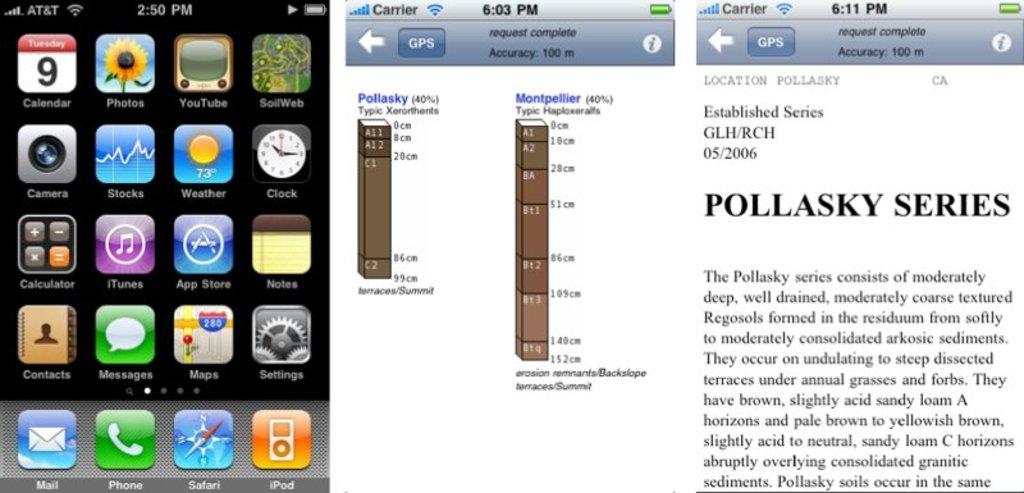What type of series is this?
Provide a succinct answer. Pollasky. 